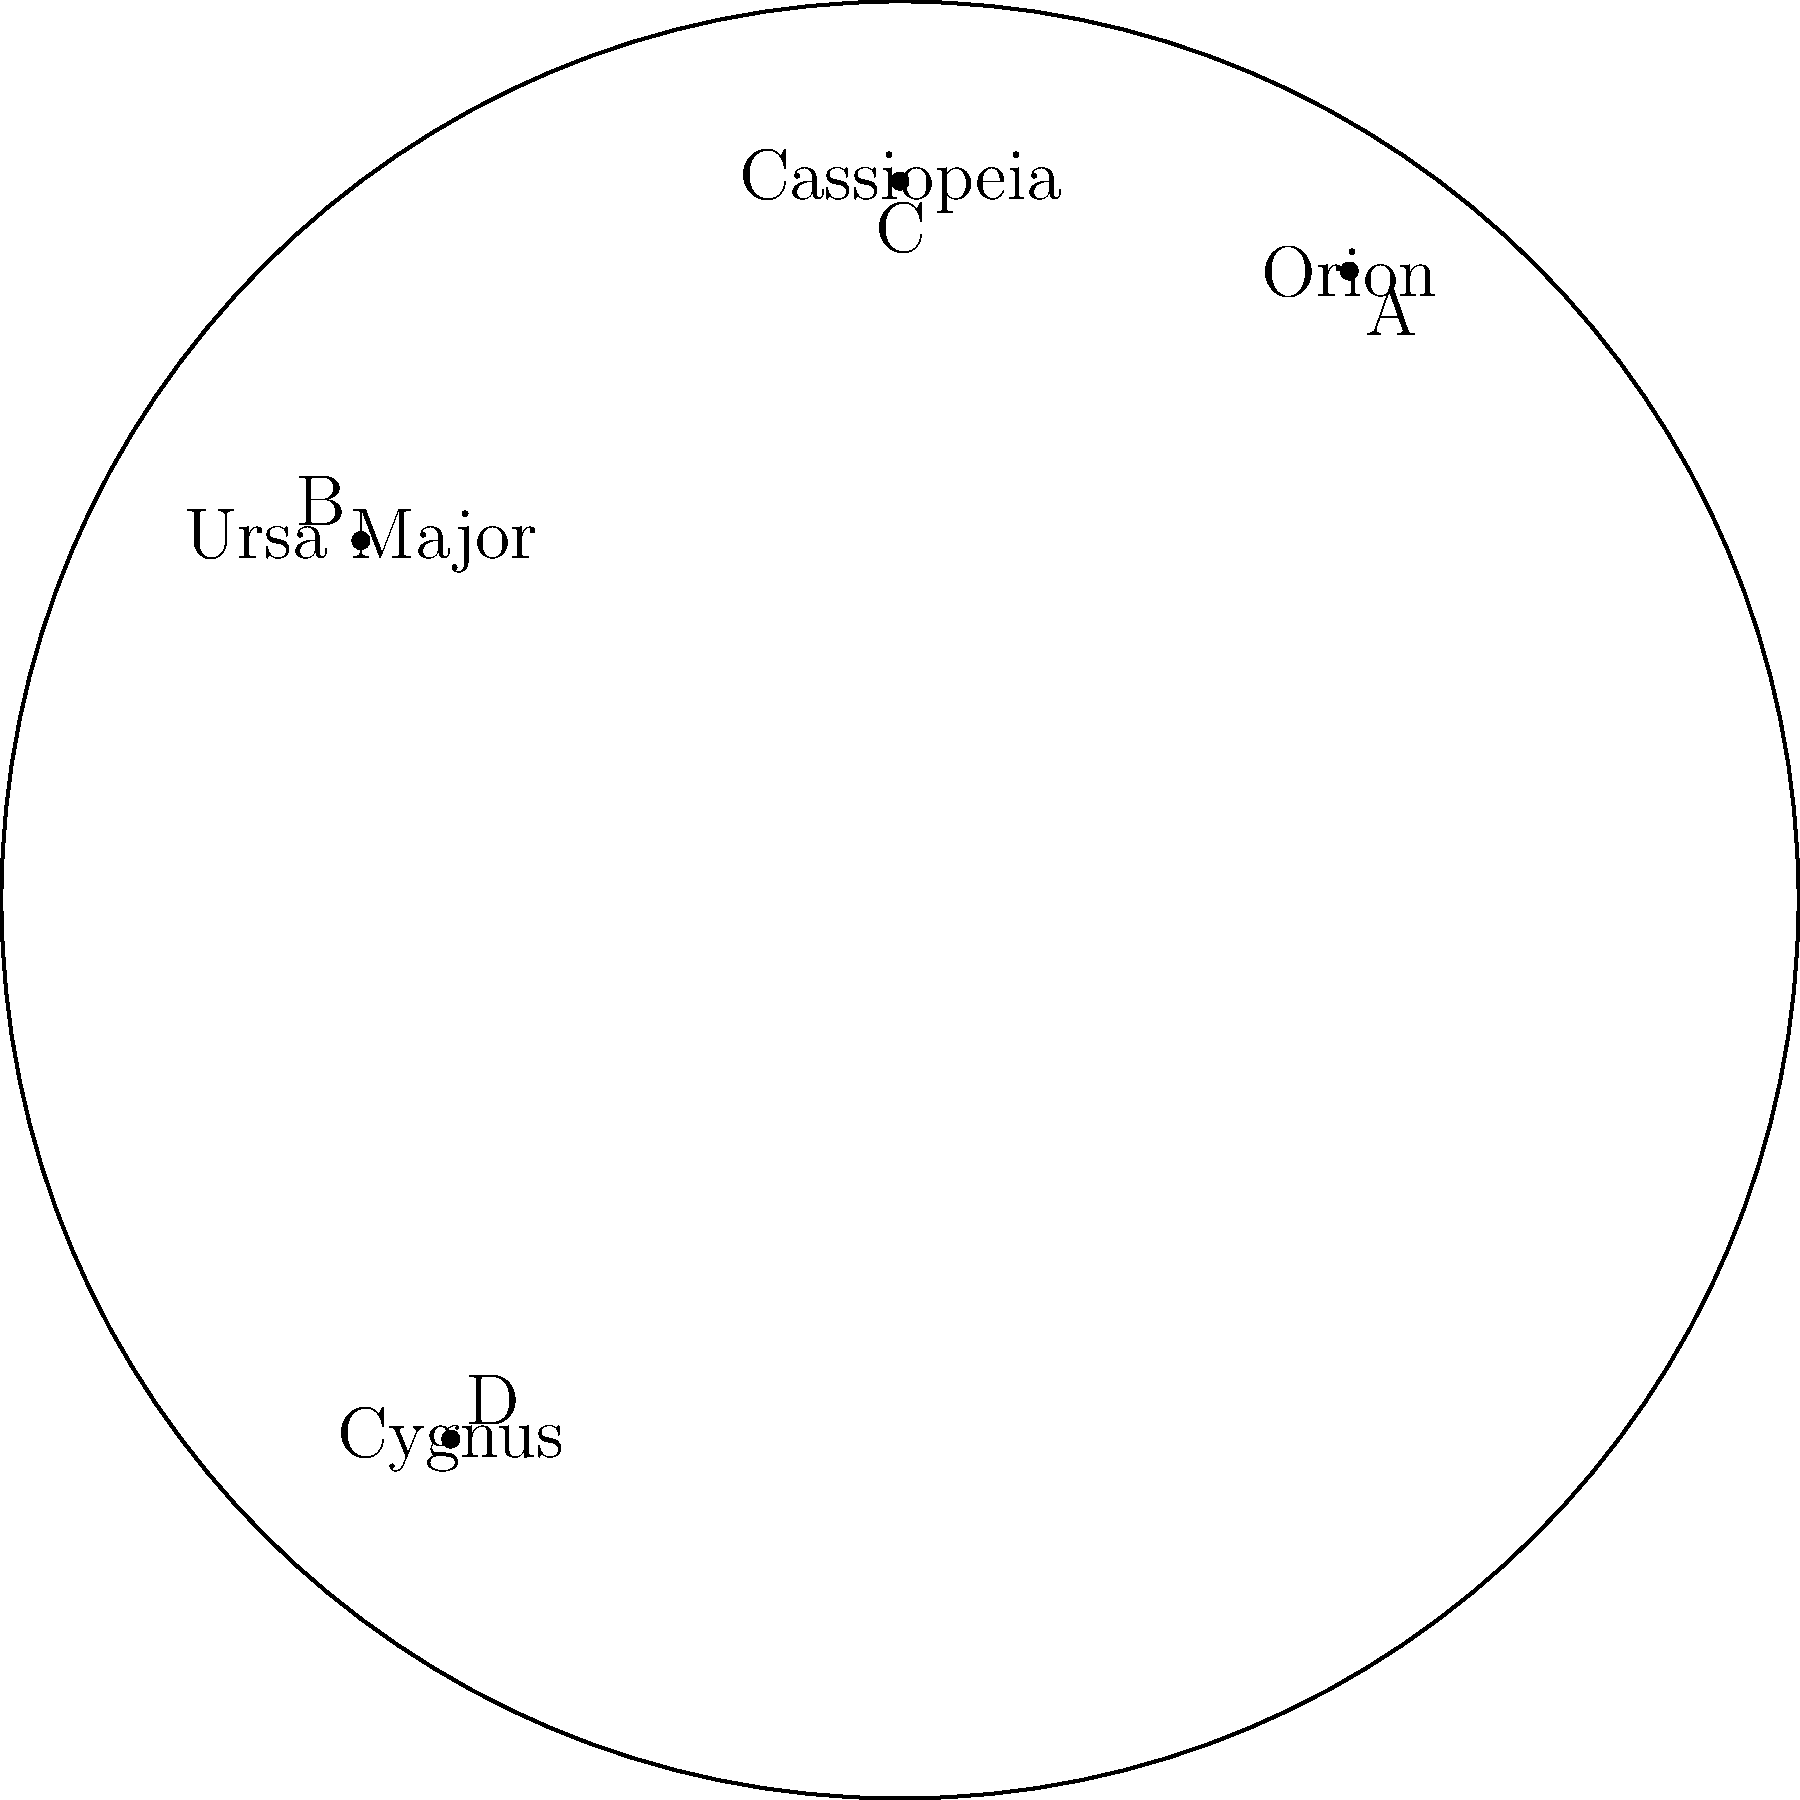Match the following ancient deities to their corresponding constellations in the star chart:

1. Artemis
2. Callisto
3. Andromeda
4. Zeus To match the ancient deities to their corresponding constellations, we need to consider the mythological associations:

1. Artemis: In Greek mythology, Artemis is the goddess of the hunt and is often associated with Orion, the hunter. In the star chart, Orion is labeled "A".

2. Callisto: In Greek mythology, Callisto was turned into a bear by Zeus and placed in the sky as Ursa Major (the Great Bear). In the star chart, Ursa Major is labeled "B".

3. Andromeda: In Greek mythology, Andromeda was a princess who was chained to a rock and later rescued by Perseus. She became the constellation Andromeda, which is near Cassiopeia. In the star chart, Cassiopeia is labeled "C".

4. Zeus: In Greek mythology, Zeus transformed himself into a swan to seduce Leda. This myth is associated with the constellation Cygnus (the Swan). In the star chart, Cygnus is labeled "D".

Therefore, the correct matching is:
1. Artemis - A (Orion)
2. Callisto - B (Ursa Major)
3. Andromeda - C (Cassiopeia)
4. Zeus - D (Cygnus)
Answer: 1-A, 2-B, 3-C, 4-D 